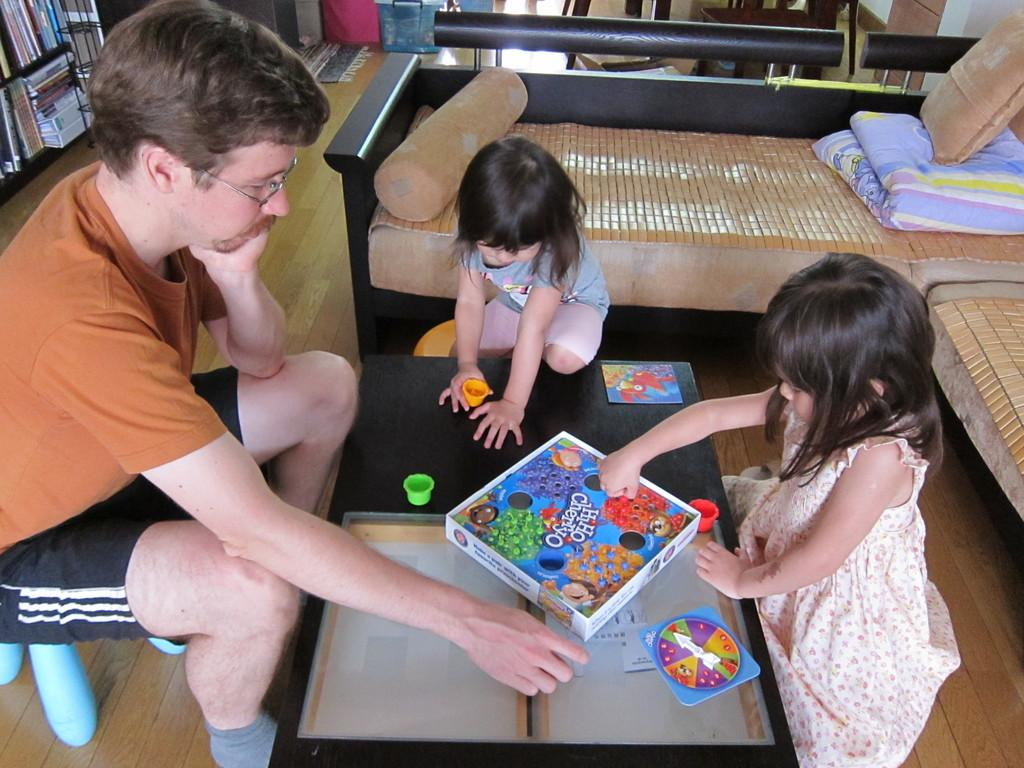How many people are in the image? There are three persons in the image. Can you describe the gender of one of the persons? One of the persons is a man. What is the age group of the other two persons? There are two children in the image. Where are the three persons located in relation to an object? All three persons are in front of a table. What type of grape is being used as a decoration on the cloth in the image? There is no grape or cloth present in the image. 